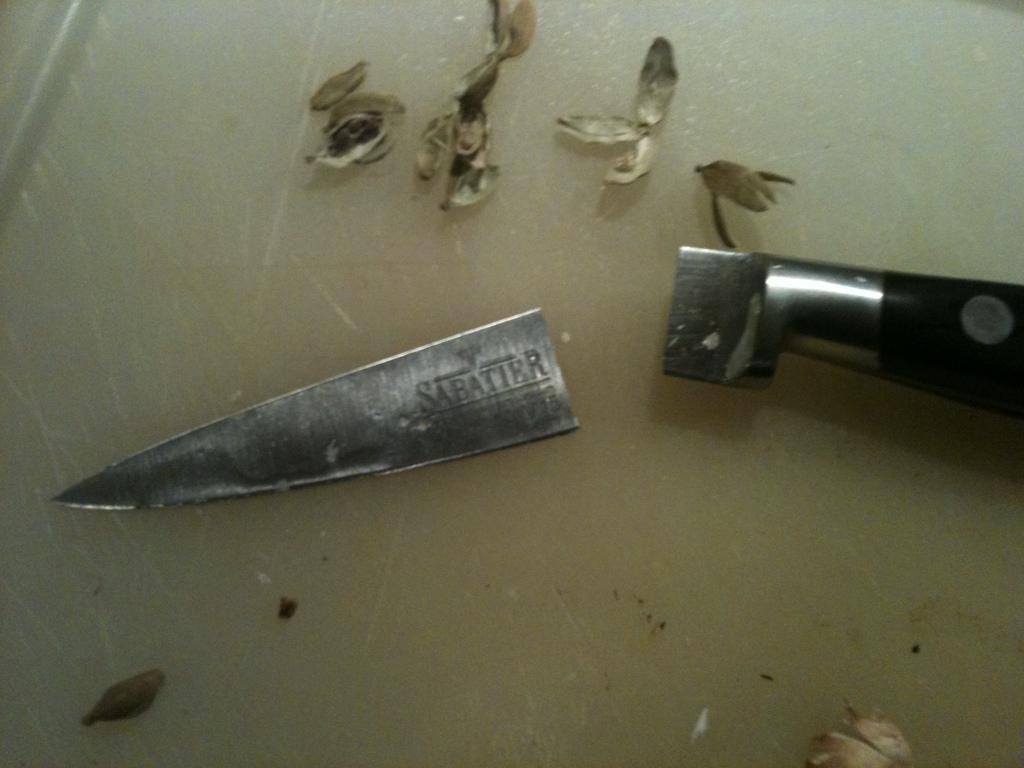Please provide a concise description of this image. There is a broken knife and cardamoms. 